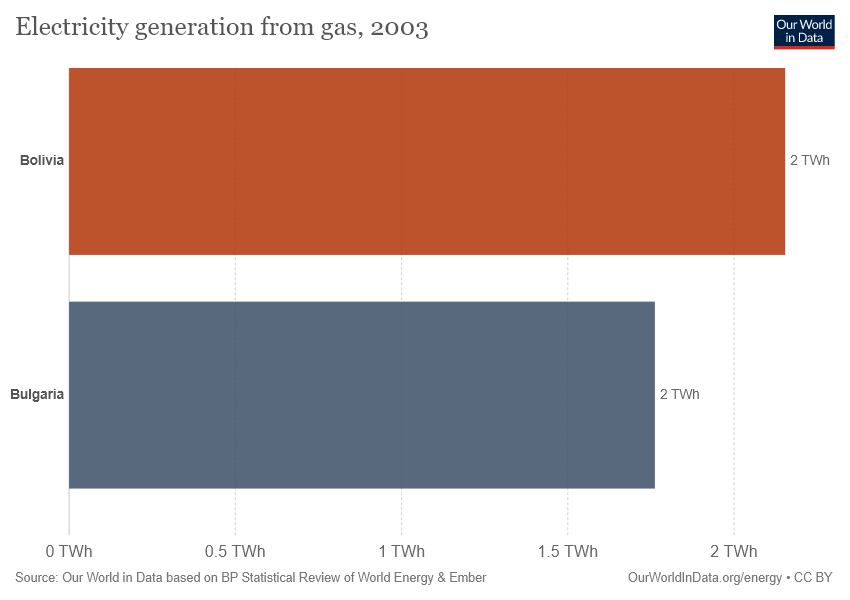Indicate a few pertinent items in this graphic. Bolivia is represented by the color brown. 